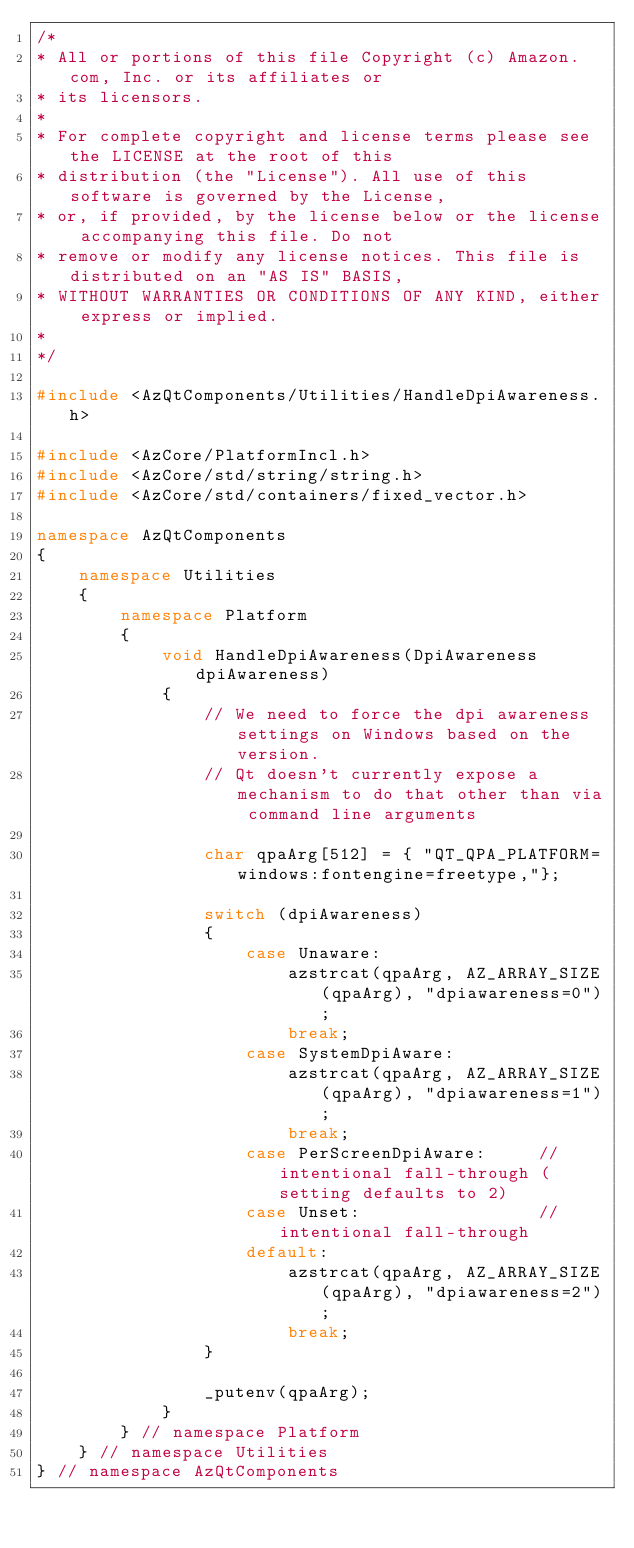<code> <loc_0><loc_0><loc_500><loc_500><_C++_>/*
* All or portions of this file Copyright (c) Amazon.com, Inc. or its affiliates or
* its licensors.
*
* For complete copyright and license terms please see the LICENSE at the root of this
* distribution (the "License"). All use of this software is governed by the License,
* or, if provided, by the license below or the license accompanying this file. Do not
* remove or modify any license notices. This file is distributed on an "AS IS" BASIS,
* WITHOUT WARRANTIES OR CONDITIONS OF ANY KIND, either express or implied.
*
*/

#include <AzQtComponents/Utilities/HandleDpiAwareness.h>

#include <AzCore/PlatformIncl.h>
#include <AzCore/std/string/string.h>
#include <AzCore/std/containers/fixed_vector.h>

namespace AzQtComponents
{
    namespace Utilities
    {
        namespace Platform
        {
            void HandleDpiAwareness(DpiAwareness dpiAwareness)
            {
                // We need to force the dpi awareness settings on Windows based on the version.
                // Qt doesn't currently expose a mechanism to do that other than via command line arguments

                char qpaArg[512] = { "QT_QPA_PLATFORM=windows:fontengine=freetype,"};

                switch (dpiAwareness)
                {
                    case Unaware:
                        azstrcat(qpaArg, AZ_ARRAY_SIZE(qpaArg), "dpiawareness=0");
                        break;
                    case SystemDpiAware:
                        azstrcat(qpaArg, AZ_ARRAY_SIZE(qpaArg), "dpiawareness=1");
                        break;
                    case PerScreenDpiAware:     // intentional fall-through (setting defaults to 2)
                    case Unset:                 // intentional fall-through
                    default:
                        azstrcat(qpaArg, AZ_ARRAY_SIZE(qpaArg), "dpiawareness=2");
                        break;
                }

                _putenv(qpaArg);
            }
        } // namespace Platform
    } // namespace Utilities
} // namespace AzQtComponents
</code> 